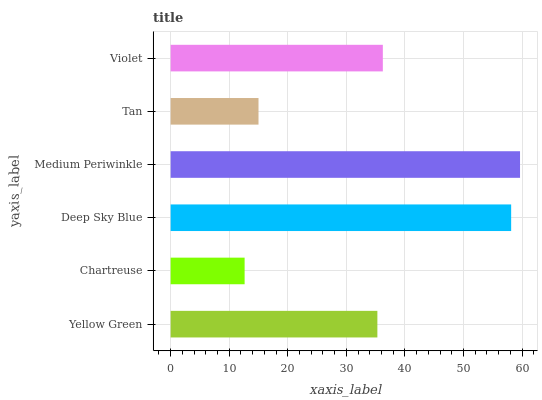Is Chartreuse the minimum?
Answer yes or no. Yes. Is Medium Periwinkle the maximum?
Answer yes or no. Yes. Is Deep Sky Blue the minimum?
Answer yes or no. No. Is Deep Sky Blue the maximum?
Answer yes or no. No. Is Deep Sky Blue greater than Chartreuse?
Answer yes or no. Yes. Is Chartreuse less than Deep Sky Blue?
Answer yes or no. Yes. Is Chartreuse greater than Deep Sky Blue?
Answer yes or no. No. Is Deep Sky Blue less than Chartreuse?
Answer yes or no. No. Is Violet the high median?
Answer yes or no. Yes. Is Yellow Green the low median?
Answer yes or no. Yes. Is Yellow Green the high median?
Answer yes or no. No. Is Tan the low median?
Answer yes or no. No. 